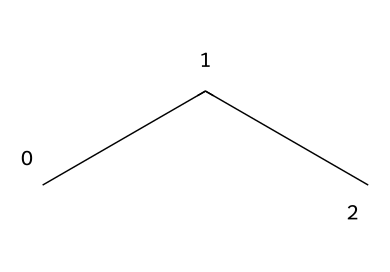What is the molecular formula of propane? By counting the number of carbon (C) and hydrogen (H) atoms in the structure, there are three carbon atoms and eight hydrogen atoms. Therefore, the molecular formula is C3H8.
Answer: C3H8 How many carbon atoms are in propane? From the SMILES representation, 'CCC' indicates there are three carbon atoms connected in a chain.
Answer: three How many hydrogen atoms are bonded to each carbon in propane? Each carbon atom in propane is connected to sufficient hydrogen atoms to fulfill the tetravalency of carbon. The terminal carbons have three hydrogen atoms each, while the middle carbon has two hydrogen atoms, totaling eight hydrogen atoms in the molecule.
Answer: two and three What type of chemical is propane classified as? Propane is a hydrocarbon because it is composed solely of carbon and hydrogen atoms. Specifically, it is classified as an alkane due to its single bonds connecting carbon atoms.
Answer: hydrocarbon Is propane a saturated or unsaturated compound? Propane is saturated because it contains only single bonds between the carbon atoms without any double or triple bonds, resulting in the maximum number of hydrogen atoms bonded to each carbon.
Answer: saturated What is the main application of propane in refrigeration? Propane is used as a refrigerant in portable cooling units due to its efficient thermodynamic properties and low environmental impact compared to other refrigerants.
Answer: refrigerant 